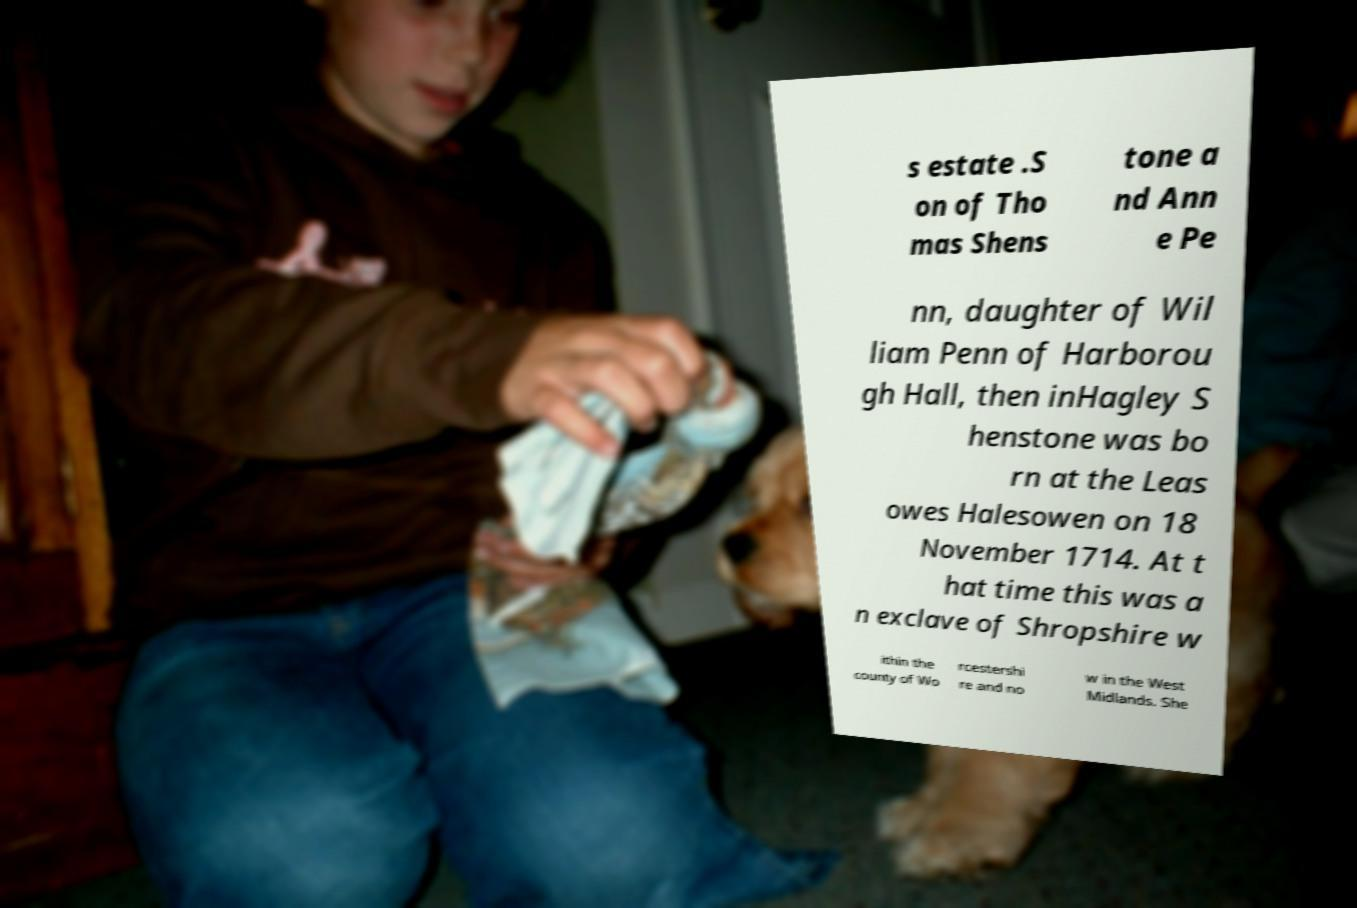I need the written content from this picture converted into text. Can you do that? s estate .S on of Tho mas Shens tone a nd Ann e Pe nn, daughter of Wil liam Penn of Harborou gh Hall, then inHagley S henstone was bo rn at the Leas owes Halesowen on 18 November 1714. At t hat time this was a n exclave of Shropshire w ithin the county of Wo rcestershi re and no w in the West Midlands. She 